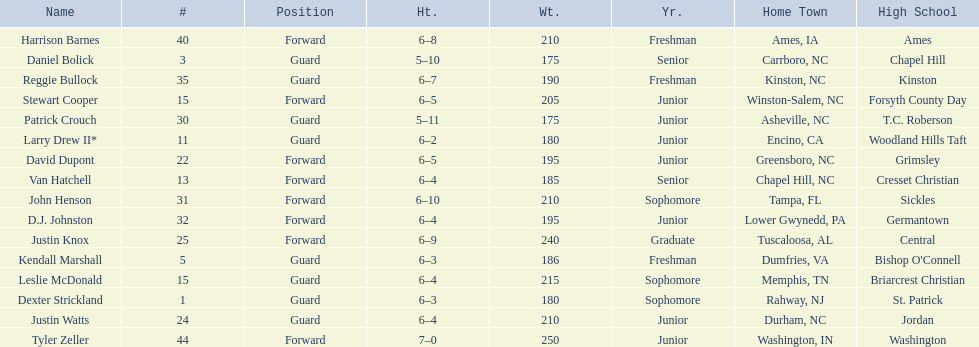Tallest player on the team Tyler Zeller. 